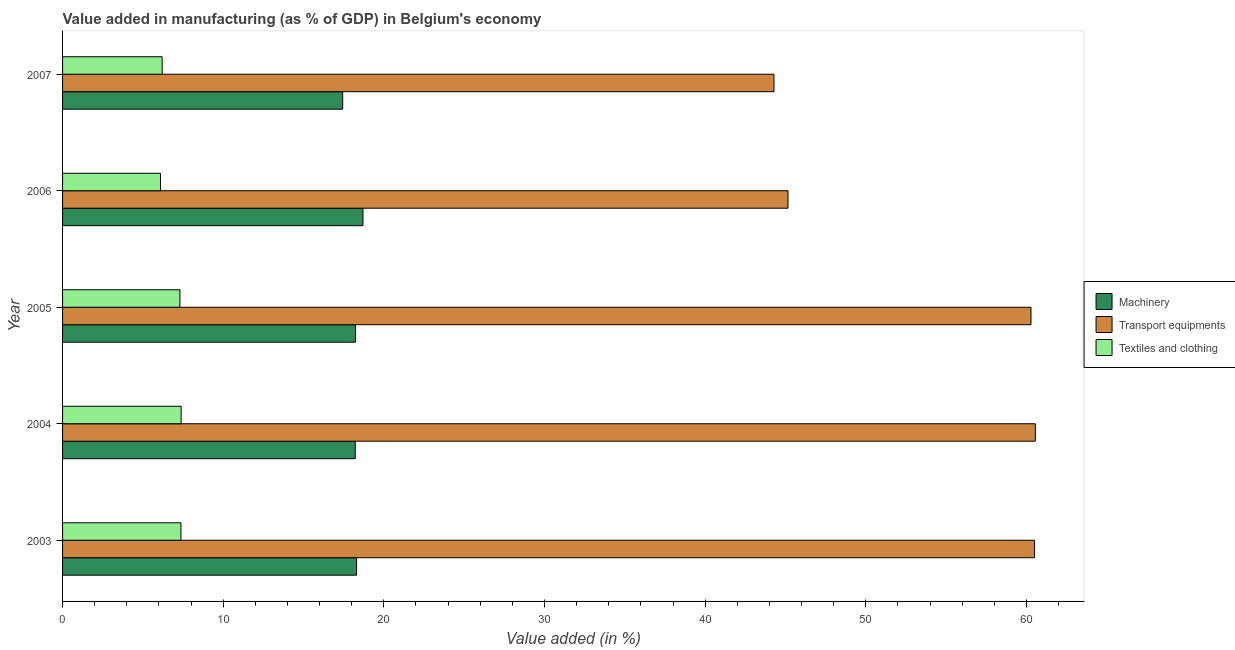How many different coloured bars are there?
Give a very brief answer. 3. Are the number of bars per tick equal to the number of legend labels?
Your answer should be compact. Yes. How many bars are there on the 3rd tick from the top?
Your answer should be compact. 3. How many bars are there on the 5th tick from the bottom?
Give a very brief answer. 3. In how many cases, is the number of bars for a given year not equal to the number of legend labels?
Keep it short and to the point. 0. What is the value added in manufacturing machinery in 2005?
Your answer should be compact. 18.24. Across all years, what is the maximum value added in manufacturing transport equipments?
Provide a succinct answer. 60.56. Across all years, what is the minimum value added in manufacturing machinery?
Ensure brevity in your answer.  17.44. In which year was the value added in manufacturing textile and clothing minimum?
Your answer should be very brief. 2006. What is the total value added in manufacturing transport equipments in the graph?
Offer a terse response. 270.8. What is the difference between the value added in manufacturing machinery in 2004 and that in 2005?
Provide a succinct answer. -0.02. What is the difference between the value added in manufacturing machinery in 2003 and the value added in manufacturing textile and clothing in 2006?
Offer a very short reply. 12.2. What is the average value added in manufacturing textile and clothing per year?
Provide a succinct answer. 6.87. In the year 2005, what is the difference between the value added in manufacturing transport equipments and value added in manufacturing machinery?
Your response must be concise. 42.05. What is the ratio of the value added in manufacturing machinery in 2004 to that in 2007?
Offer a terse response. 1.04. What is the difference between the highest and the second highest value added in manufacturing textile and clothing?
Offer a terse response. 0.01. What is the difference between the highest and the lowest value added in manufacturing transport equipments?
Your response must be concise. 16.27. In how many years, is the value added in manufacturing machinery greater than the average value added in manufacturing machinery taken over all years?
Your answer should be very brief. 4. Is the sum of the value added in manufacturing textile and clothing in 2004 and 2007 greater than the maximum value added in manufacturing transport equipments across all years?
Ensure brevity in your answer.  No. What does the 2nd bar from the top in 2004 represents?
Your response must be concise. Transport equipments. What does the 1st bar from the bottom in 2006 represents?
Your answer should be compact. Machinery. Is it the case that in every year, the sum of the value added in manufacturing machinery and value added in manufacturing transport equipments is greater than the value added in manufacturing textile and clothing?
Your response must be concise. Yes. How many bars are there?
Ensure brevity in your answer.  15. Are the values on the major ticks of X-axis written in scientific E-notation?
Provide a short and direct response. No. Does the graph contain any zero values?
Offer a terse response. No. Does the graph contain grids?
Provide a short and direct response. No. How many legend labels are there?
Keep it short and to the point. 3. What is the title of the graph?
Keep it short and to the point. Value added in manufacturing (as % of GDP) in Belgium's economy. Does "Travel services" appear as one of the legend labels in the graph?
Make the answer very short. No. What is the label or title of the X-axis?
Offer a very short reply. Value added (in %). What is the Value added (in %) in Machinery in 2003?
Provide a short and direct response. 18.3. What is the Value added (in %) in Transport equipments in 2003?
Provide a succinct answer. 60.51. What is the Value added (in %) in Textiles and clothing in 2003?
Keep it short and to the point. 7.37. What is the Value added (in %) of Machinery in 2004?
Offer a very short reply. 18.22. What is the Value added (in %) of Transport equipments in 2004?
Give a very brief answer. 60.56. What is the Value added (in %) in Textiles and clothing in 2004?
Make the answer very short. 7.38. What is the Value added (in %) of Machinery in 2005?
Your answer should be compact. 18.24. What is the Value added (in %) in Transport equipments in 2005?
Your answer should be very brief. 60.29. What is the Value added (in %) of Textiles and clothing in 2005?
Offer a very short reply. 7.3. What is the Value added (in %) in Machinery in 2006?
Your answer should be compact. 18.7. What is the Value added (in %) of Transport equipments in 2006?
Your answer should be compact. 45.16. What is the Value added (in %) of Textiles and clothing in 2006?
Your answer should be very brief. 6.1. What is the Value added (in %) in Machinery in 2007?
Provide a succinct answer. 17.44. What is the Value added (in %) in Transport equipments in 2007?
Ensure brevity in your answer.  44.29. What is the Value added (in %) of Textiles and clothing in 2007?
Your answer should be compact. 6.2. Across all years, what is the maximum Value added (in %) of Machinery?
Your answer should be compact. 18.7. Across all years, what is the maximum Value added (in %) in Transport equipments?
Keep it short and to the point. 60.56. Across all years, what is the maximum Value added (in %) of Textiles and clothing?
Offer a very short reply. 7.38. Across all years, what is the minimum Value added (in %) in Machinery?
Make the answer very short. 17.44. Across all years, what is the minimum Value added (in %) in Transport equipments?
Offer a terse response. 44.29. Across all years, what is the minimum Value added (in %) of Textiles and clothing?
Provide a succinct answer. 6.1. What is the total Value added (in %) in Machinery in the graph?
Your response must be concise. 90.9. What is the total Value added (in %) of Transport equipments in the graph?
Your answer should be compact. 270.8. What is the total Value added (in %) of Textiles and clothing in the graph?
Make the answer very short. 34.35. What is the difference between the Value added (in %) of Machinery in 2003 and that in 2004?
Provide a short and direct response. 0.08. What is the difference between the Value added (in %) in Transport equipments in 2003 and that in 2004?
Offer a very short reply. -0.05. What is the difference between the Value added (in %) of Textiles and clothing in 2003 and that in 2004?
Provide a short and direct response. -0.01. What is the difference between the Value added (in %) of Machinery in 2003 and that in 2005?
Your response must be concise. 0.06. What is the difference between the Value added (in %) of Transport equipments in 2003 and that in 2005?
Ensure brevity in your answer.  0.22. What is the difference between the Value added (in %) in Textiles and clothing in 2003 and that in 2005?
Keep it short and to the point. 0.06. What is the difference between the Value added (in %) of Transport equipments in 2003 and that in 2006?
Your answer should be compact. 15.35. What is the difference between the Value added (in %) in Textiles and clothing in 2003 and that in 2006?
Make the answer very short. 1.27. What is the difference between the Value added (in %) in Machinery in 2003 and that in 2007?
Your answer should be compact. 0.86. What is the difference between the Value added (in %) in Transport equipments in 2003 and that in 2007?
Your answer should be compact. 16.22. What is the difference between the Value added (in %) of Textiles and clothing in 2003 and that in 2007?
Your answer should be compact. 1.17. What is the difference between the Value added (in %) of Machinery in 2004 and that in 2005?
Provide a short and direct response. -0.02. What is the difference between the Value added (in %) of Transport equipments in 2004 and that in 2005?
Offer a very short reply. 0.27. What is the difference between the Value added (in %) of Textiles and clothing in 2004 and that in 2005?
Offer a terse response. 0.08. What is the difference between the Value added (in %) of Machinery in 2004 and that in 2006?
Make the answer very short. -0.48. What is the difference between the Value added (in %) in Transport equipments in 2004 and that in 2006?
Your answer should be compact. 15.4. What is the difference between the Value added (in %) in Textiles and clothing in 2004 and that in 2006?
Make the answer very short. 1.28. What is the difference between the Value added (in %) of Machinery in 2004 and that in 2007?
Make the answer very short. 0.78. What is the difference between the Value added (in %) of Transport equipments in 2004 and that in 2007?
Your answer should be very brief. 16.27. What is the difference between the Value added (in %) of Textiles and clothing in 2004 and that in 2007?
Provide a short and direct response. 1.18. What is the difference between the Value added (in %) of Machinery in 2005 and that in 2006?
Give a very brief answer. -0.46. What is the difference between the Value added (in %) in Transport equipments in 2005 and that in 2006?
Offer a terse response. 15.13. What is the difference between the Value added (in %) in Textiles and clothing in 2005 and that in 2006?
Ensure brevity in your answer.  1.21. What is the difference between the Value added (in %) in Machinery in 2005 and that in 2007?
Make the answer very short. 0.8. What is the difference between the Value added (in %) of Transport equipments in 2005 and that in 2007?
Ensure brevity in your answer.  16. What is the difference between the Value added (in %) in Textiles and clothing in 2005 and that in 2007?
Provide a short and direct response. 1.11. What is the difference between the Value added (in %) in Machinery in 2006 and that in 2007?
Offer a terse response. 1.26. What is the difference between the Value added (in %) in Transport equipments in 2006 and that in 2007?
Your answer should be compact. 0.87. What is the difference between the Value added (in %) of Textiles and clothing in 2006 and that in 2007?
Offer a very short reply. -0.1. What is the difference between the Value added (in %) of Machinery in 2003 and the Value added (in %) of Transport equipments in 2004?
Keep it short and to the point. -42.26. What is the difference between the Value added (in %) of Machinery in 2003 and the Value added (in %) of Textiles and clothing in 2004?
Keep it short and to the point. 10.92. What is the difference between the Value added (in %) in Transport equipments in 2003 and the Value added (in %) in Textiles and clothing in 2004?
Provide a succinct answer. 53.13. What is the difference between the Value added (in %) in Machinery in 2003 and the Value added (in %) in Transport equipments in 2005?
Provide a succinct answer. -41.98. What is the difference between the Value added (in %) of Machinery in 2003 and the Value added (in %) of Textiles and clothing in 2005?
Ensure brevity in your answer.  11. What is the difference between the Value added (in %) of Transport equipments in 2003 and the Value added (in %) of Textiles and clothing in 2005?
Provide a short and direct response. 53.2. What is the difference between the Value added (in %) of Machinery in 2003 and the Value added (in %) of Transport equipments in 2006?
Provide a short and direct response. -26.86. What is the difference between the Value added (in %) of Machinery in 2003 and the Value added (in %) of Textiles and clothing in 2006?
Your answer should be compact. 12.2. What is the difference between the Value added (in %) in Transport equipments in 2003 and the Value added (in %) in Textiles and clothing in 2006?
Your answer should be compact. 54.41. What is the difference between the Value added (in %) of Machinery in 2003 and the Value added (in %) of Transport equipments in 2007?
Your response must be concise. -25.99. What is the difference between the Value added (in %) of Machinery in 2003 and the Value added (in %) of Textiles and clothing in 2007?
Your answer should be very brief. 12.1. What is the difference between the Value added (in %) of Transport equipments in 2003 and the Value added (in %) of Textiles and clothing in 2007?
Offer a very short reply. 54.31. What is the difference between the Value added (in %) of Machinery in 2004 and the Value added (in %) of Transport equipments in 2005?
Your answer should be very brief. -42.07. What is the difference between the Value added (in %) in Machinery in 2004 and the Value added (in %) in Textiles and clothing in 2005?
Your response must be concise. 10.92. What is the difference between the Value added (in %) of Transport equipments in 2004 and the Value added (in %) of Textiles and clothing in 2005?
Provide a short and direct response. 53.26. What is the difference between the Value added (in %) in Machinery in 2004 and the Value added (in %) in Transport equipments in 2006?
Your answer should be very brief. -26.94. What is the difference between the Value added (in %) in Machinery in 2004 and the Value added (in %) in Textiles and clothing in 2006?
Your answer should be compact. 12.12. What is the difference between the Value added (in %) of Transport equipments in 2004 and the Value added (in %) of Textiles and clothing in 2006?
Ensure brevity in your answer.  54.46. What is the difference between the Value added (in %) of Machinery in 2004 and the Value added (in %) of Transport equipments in 2007?
Your response must be concise. -26.07. What is the difference between the Value added (in %) of Machinery in 2004 and the Value added (in %) of Textiles and clothing in 2007?
Ensure brevity in your answer.  12.02. What is the difference between the Value added (in %) in Transport equipments in 2004 and the Value added (in %) in Textiles and clothing in 2007?
Keep it short and to the point. 54.36. What is the difference between the Value added (in %) in Machinery in 2005 and the Value added (in %) in Transport equipments in 2006?
Ensure brevity in your answer.  -26.92. What is the difference between the Value added (in %) of Machinery in 2005 and the Value added (in %) of Textiles and clothing in 2006?
Make the answer very short. 12.14. What is the difference between the Value added (in %) of Transport equipments in 2005 and the Value added (in %) of Textiles and clothing in 2006?
Your answer should be very brief. 54.19. What is the difference between the Value added (in %) of Machinery in 2005 and the Value added (in %) of Transport equipments in 2007?
Your answer should be very brief. -26.05. What is the difference between the Value added (in %) of Machinery in 2005 and the Value added (in %) of Textiles and clothing in 2007?
Keep it short and to the point. 12.04. What is the difference between the Value added (in %) in Transport equipments in 2005 and the Value added (in %) in Textiles and clothing in 2007?
Provide a short and direct response. 54.09. What is the difference between the Value added (in %) in Machinery in 2006 and the Value added (in %) in Transport equipments in 2007?
Offer a terse response. -25.59. What is the difference between the Value added (in %) in Machinery in 2006 and the Value added (in %) in Textiles and clothing in 2007?
Your answer should be very brief. 12.5. What is the difference between the Value added (in %) in Transport equipments in 2006 and the Value added (in %) in Textiles and clothing in 2007?
Offer a terse response. 38.96. What is the average Value added (in %) in Machinery per year?
Your response must be concise. 18.18. What is the average Value added (in %) in Transport equipments per year?
Ensure brevity in your answer.  54.16. What is the average Value added (in %) in Textiles and clothing per year?
Your answer should be very brief. 6.87. In the year 2003, what is the difference between the Value added (in %) of Machinery and Value added (in %) of Transport equipments?
Your answer should be compact. -42.21. In the year 2003, what is the difference between the Value added (in %) of Machinery and Value added (in %) of Textiles and clothing?
Ensure brevity in your answer.  10.93. In the year 2003, what is the difference between the Value added (in %) in Transport equipments and Value added (in %) in Textiles and clothing?
Your answer should be very brief. 53.14. In the year 2004, what is the difference between the Value added (in %) in Machinery and Value added (in %) in Transport equipments?
Make the answer very short. -42.34. In the year 2004, what is the difference between the Value added (in %) of Machinery and Value added (in %) of Textiles and clothing?
Offer a very short reply. 10.84. In the year 2004, what is the difference between the Value added (in %) of Transport equipments and Value added (in %) of Textiles and clothing?
Provide a short and direct response. 53.18. In the year 2005, what is the difference between the Value added (in %) of Machinery and Value added (in %) of Transport equipments?
Make the answer very short. -42.05. In the year 2005, what is the difference between the Value added (in %) in Machinery and Value added (in %) in Textiles and clothing?
Your answer should be compact. 10.93. In the year 2005, what is the difference between the Value added (in %) of Transport equipments and Value added (in %) of Textiles and clothing?
Make the answer very short. 52.98. In the year 2006, what is the difference between the Value added (in %) in Machinery and Value added (in %) in Transport equipments?
Give a very brief answer. -26.46. In the year 2006, what is the difference between the Value added (in %) in Machinery and Value added (in %) in Textiles and clothing?
Make the answer very short. 12.6. In the year 2006, what is the difference between the Value added (in %) of Transport equipments and Value added (in %) of Textiles and clothing?
Ensure brevity in your answer.  39.06. In the year 2007, what is the difference between the Value added (in %) in Machinery and Value added (in %) in Transport equipments?
Provide a succinct answer. -26.85. In the year 2007, what is the difference between the Value added (in %) in Machinery and Value added (in %) in Textiles and clothing?
Provide a short and direct response. 11.24. In the year 2007, what is the difference between the Value added (in %) in Transport equipments and Value added (in %) in Textiles and clothing?
Your response must be concise. 38.09. What is the ratio of the Value added (in %) in Machinery in 2003 to that in 2004?
Offer a terse response. 1. What is the ratio of the Value added (in %) in Transport equipments in 2003 to that in 2004?
Your response must be concise. 1. What is the ratio of the Value added (in %) in Machinery in 2003 to that in 2005?
Offer a terse response. 1. What is the ratio of the Value added (in %) of Textiles and clothing in 2003 to that in 2005?
Offer a terse response. 1.01. What is the ratio of the Value added (in %) of Machinery in 2003 to that in 2006?
Give a very brief answer. 0.98. What is the ratio of the Value added (in %) of Transport equipments in 2003 to that in 2006?
Provide a succinct answer. 1.34. What is the ratio of the Value added (in %) of Textiles and clothing in 2003 to that in 2006?
Offer a very short reply. 1.21. What is the ratio of the Value added (in %) in Machinery in 2003 to that in 2007?
Ensure brevity in your answer.  1.05. What is the ratio of the Value added (in %) in Transport equipments in 2003 to that in 2007?
Ensure brevity in your answer.  1.37. What is the ratio of the Value added (in %) of Textiles and clothing in 2003 to that in 2007?
Your answer should be compact. 1.19. What is the ratio of the Value added (in %) of Machinery in 2004 to that in 2005?
Give a very brief answer. 1. What is the ratio of the Value added (in %) of Textiles and clothing in 2004 to that in 2005?
Offer a terse response. 1.01. What is the ratio of the Value added (in %) in Machinery in 2004 to that in 2006?
Offer a very short reply. 0.97. What is the ratio of the Value added (in %) in Transport equipments in 2004 to that in 2006?
Make the answer very short. 1.34. What is the ratio of the Value added (in %) in Textiles and clothing in 2004 to that in 2006?
Give a very brief answer. 1.21. What is the ratio of the Value added (in %) of Machinery in 2004 to that in 2007?
Provide a short and direct response. 1.04. What is the ratio of the Value added (in %) of Transport equipments in 2004 to that in 2007?
Your response must be concise. 1.37. What is the ratio of the Value added (in %) of Textiles and clothing in 2004 to that in 2007?
Offer a very short reply. 1.19. What is the ratio of the Value added (in %) of Machinery in 2005 to that in 2006?
Make the answer very short. 0.98. What is the ratio of the Value added (in %) of Transport equipments in 2005 to that in 2006?
Keep it short and to the point. 1.33. What is the ratio of the Value added (in %) of Textiles and clothing in 2005 to that in 2006?
Your answer should be very brief. 1.2. What is the ratio of the Value added (in %) of Machinery in 2005 to that in 2007?
Your answer should be compact. 1.05. What is the ratio of the Value added (in %) in Transport equipments in 2005 to that in 2007?
Keep it short and to the point. 1.36. What is the ratio of the Value added (in %) in Textiles and clothing in 2005 to that in 2007?
Keep it short and to the point. 1.18. What is the ratio of the Value added (in %) of Machinery in 2006 to that in 2007?
Ensure brevity in your answer.  1.07. What is the ratio of the Value added (in %) in Transport equipments in 2006 to that in 2007?
Your answer should be very brief. 1.02. What is the ratio of the Value added (in %) in Textiles and clothing in 2006 to that in 2007?
Provide a succinct answer. 0.98. What is the difference between the highest and the second highest Value added (in %) in Transport equipments?
Keep it short and to the point. 0.05. What is the difference between the highest and the second highest Value added (in %) of Textiles and clothing?
Offer a terse response. 0.01. What is the difference between the highest and the lowest Value added (in %) in Machinery?
Make the answer very short. 1.26. What is the difference between the highest and the lowest Value added (in %) of Transport equipments?
Give a very brief answer. 16.27. What is the difference between the highest and the lowest Value added (in %) of Textiles and clothing?
Your response must be concise. 1.28. 